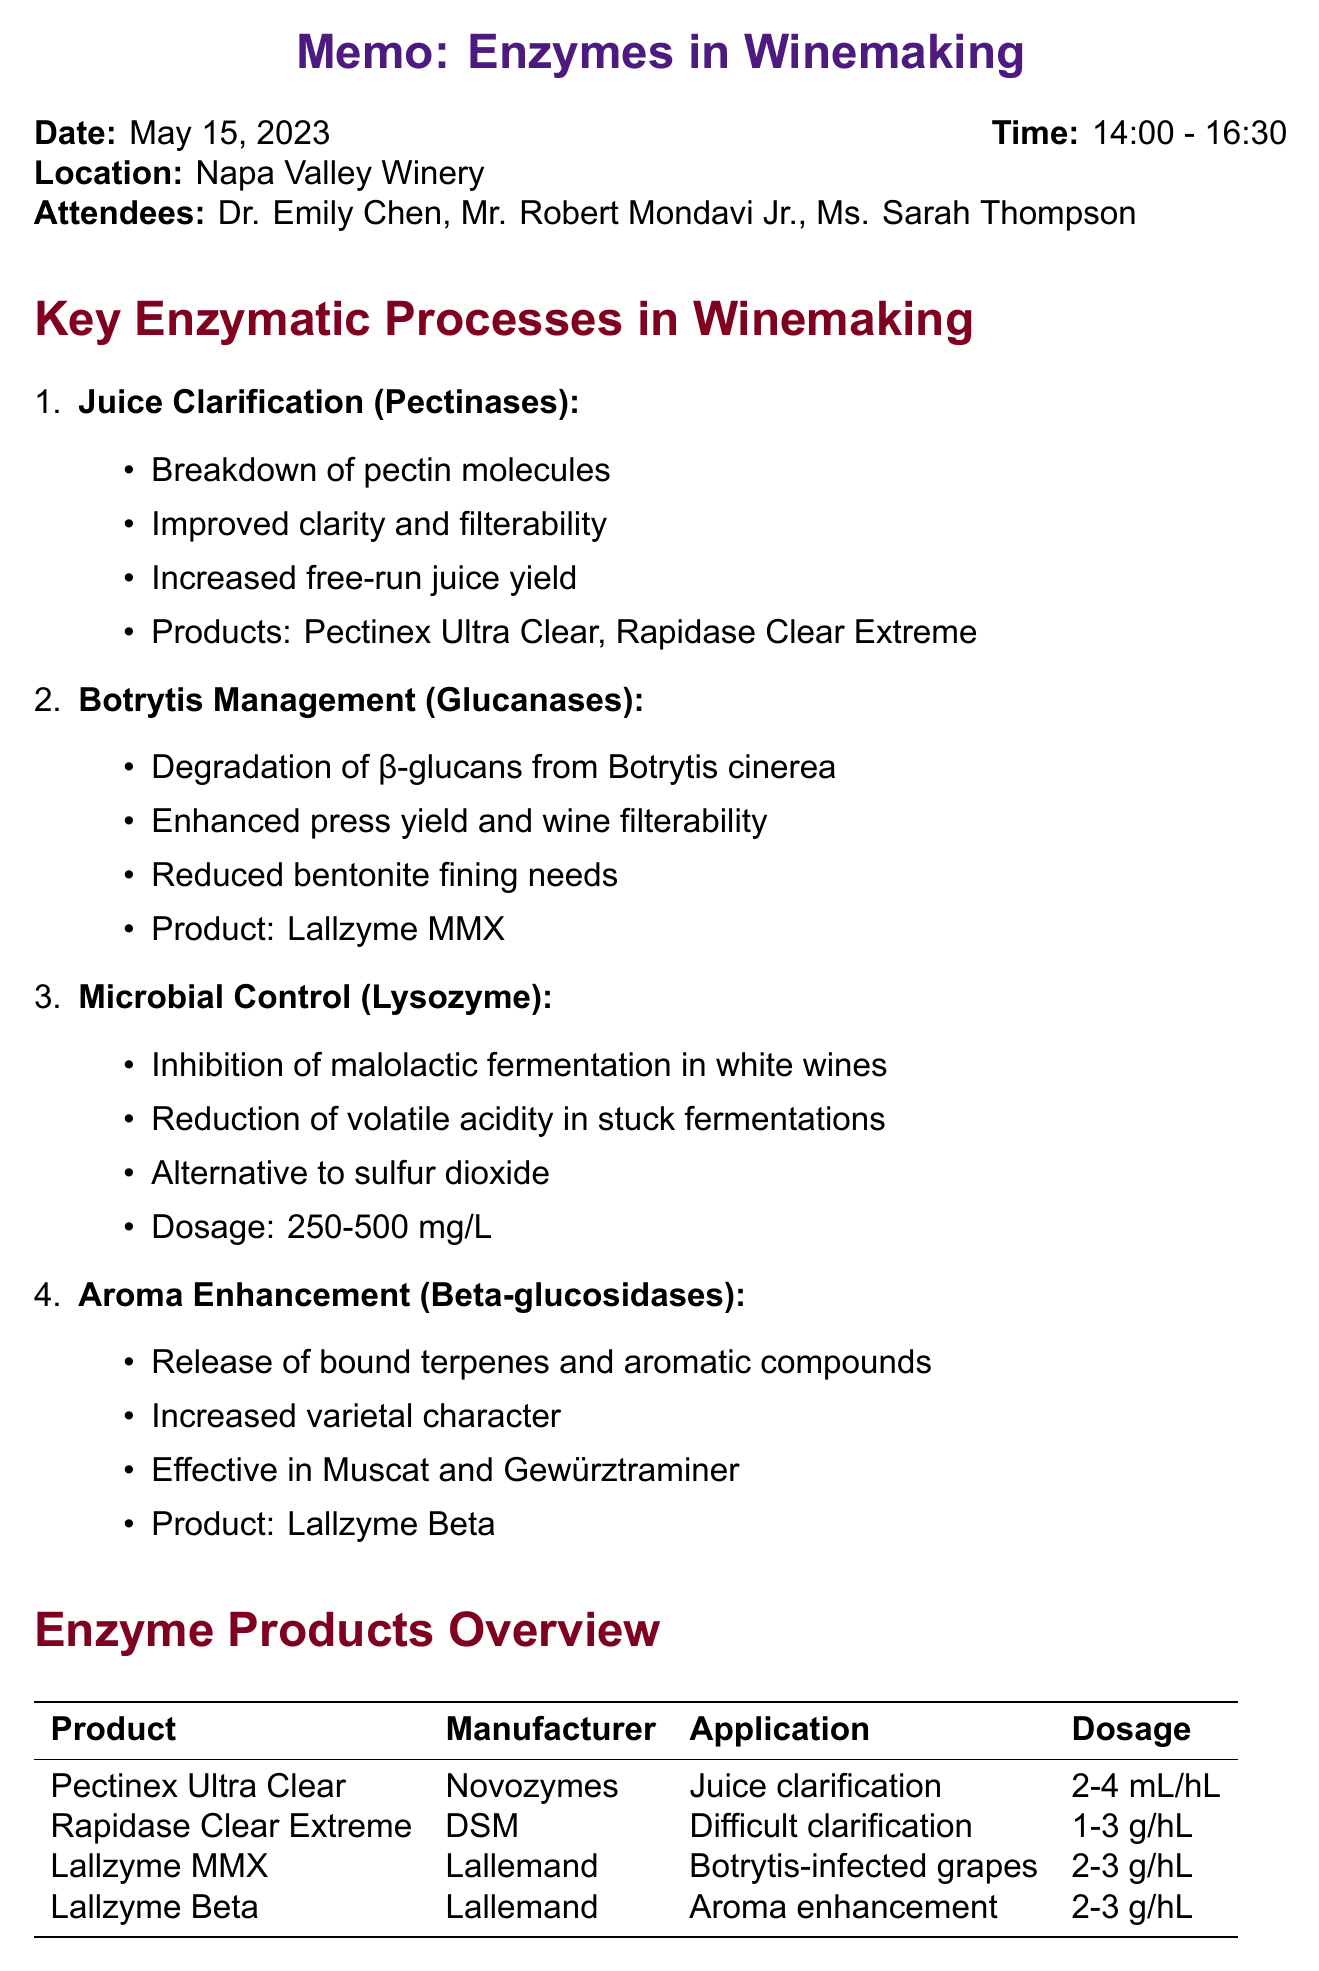What was the date of the meeting? The date of the meeting, located at the beginning of the memo, is stated clearly.
Answer: May 15, 2023 Who attended the meeting? The attendees of the meeting are listed in the meeting details section.
Answer: Dr. Emily Chen, Mr. Robert Mondavi Jr., Ms. Sarah Thompson What is the application of Lallzyme MMX? The application of Lallzyme MMX is discussed in the enzyme products overview section of the memo.
Answer: Botrytis-infected grapes What is the dosage for Pectinex Ultra Clear? The dosage for Pectinex Ultra Clear is specified in the enzyme products overview table.
Answer: 2-4 mL/hL What is one of the future research opportunities mentioned? Future research opportunities are listed towards the end of the memo.
Answer: Synergistic effects between enzyme preparations What is the main focus of the memo? The memo primarily discusses the use of enzymes in winemaking, which is detailed in the title and body.
Answer: Enzymes in Winemaking How long did the meeting last? The duration of the meeting can be calculated from the stated start and end times.
Answer: 2 hours and 30 minutes What enzyme is specifically effective in Muscat and Gewürztraminer? The document lists specific enzymes related to aroma enhancement and their effectiveness in certain varieties.
Answer: Lallzyme Beta 